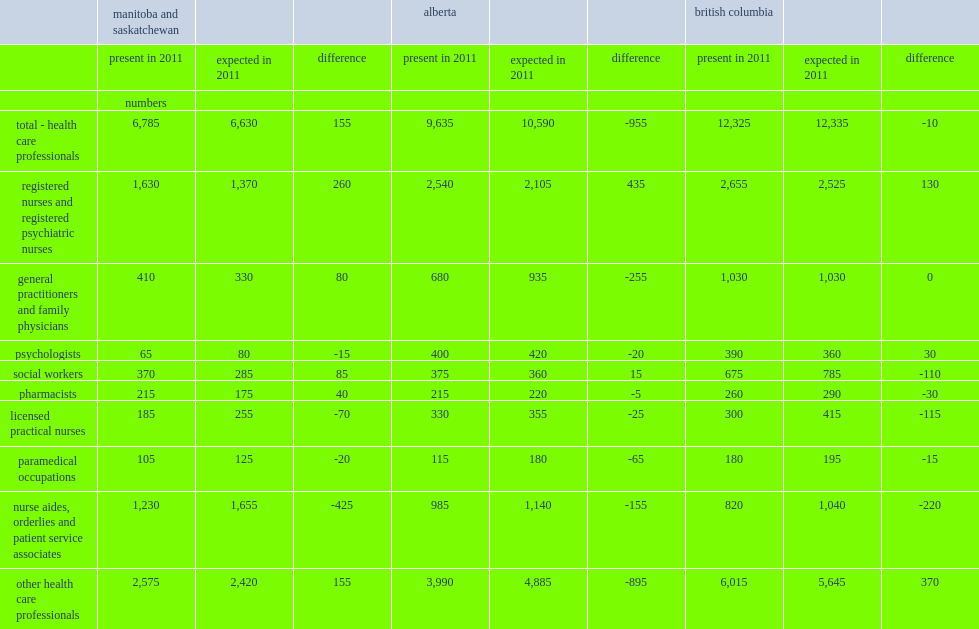How many professionals were able to conduct a conversation in french in 2011? 6785.0. How many professionals were expected to be able to conduct a conversation in french in 2011? 6630.0. What was the number of a shortfall of professionals compared with the 10,590 expected in 2011? 955. 